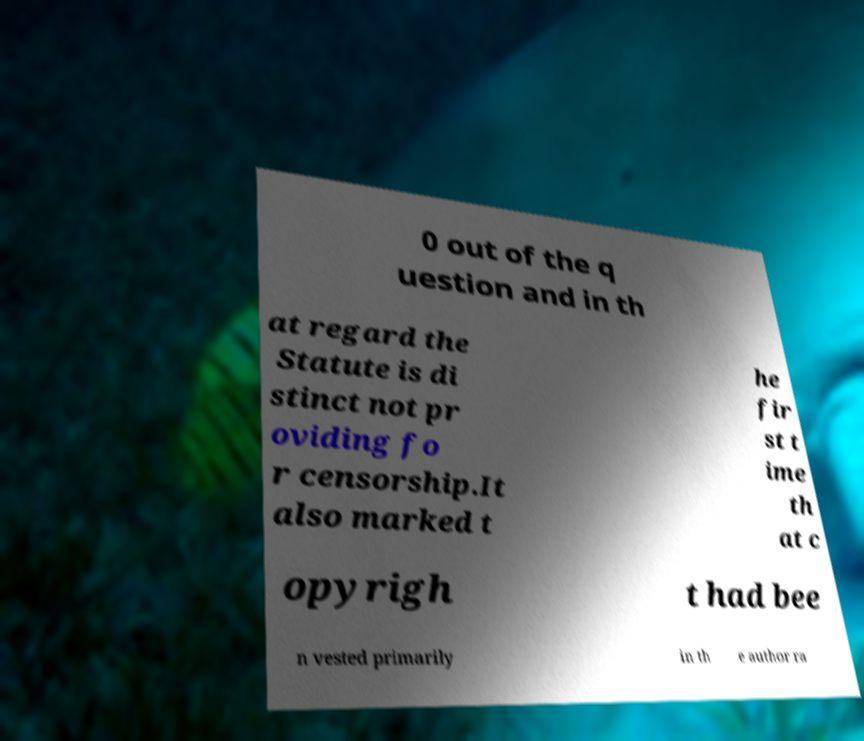Can you accurately transcribe the text from the provided image for me? 0 out of the q uestion and in th at regard the Statute is di stinct not pr oviding fo r censorship.It also marked t he fir st t ime th at c opyrigh t had bee n vested primarily in th e author ra 